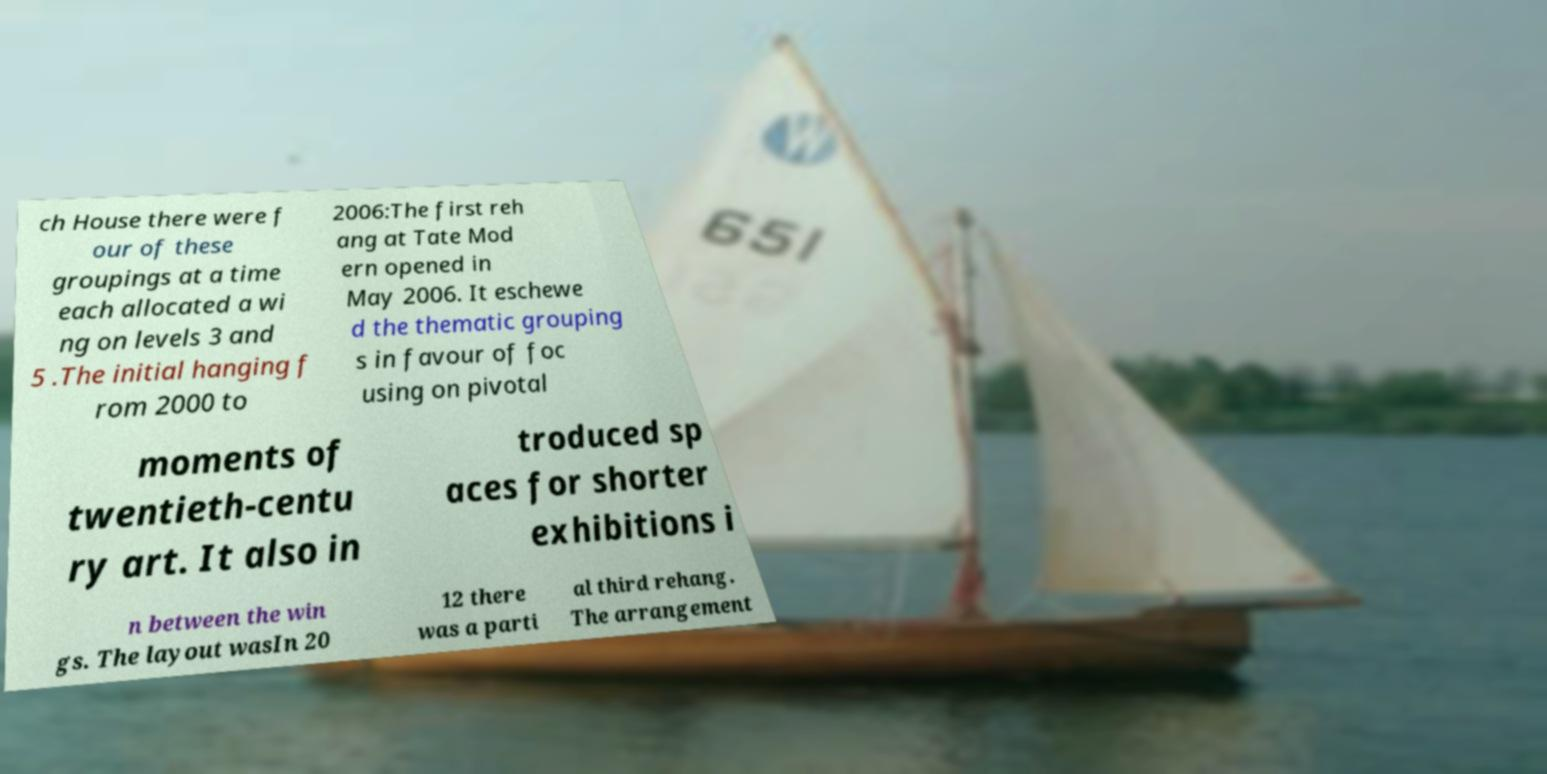I need the written content from this picture converted into text. Can you do that? ch House there were f our of these groupings at a time each allocated a wi ng on levels 3 and 5 .The initial hanging f rom 2000 to 2006:The first reh ang at Tate Mod ern opened in May 2006. It eschewe d the thematic grouping s in favour of foc using on pivotal moments of twentieth-centu ry art. It also in troduced sp aces for shorter exhibitions i n between the win gs. The layout wasIn 20 12 there was a parti al third rehang. The arrangement 